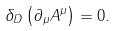Convert formula to latex. <formula><loc_0><loc_0><loc_500><loc_500>\delta _ { D } \left ( { \partial _ { \mu } A ^ { \mu } } \right ) = 0 .</formula> 